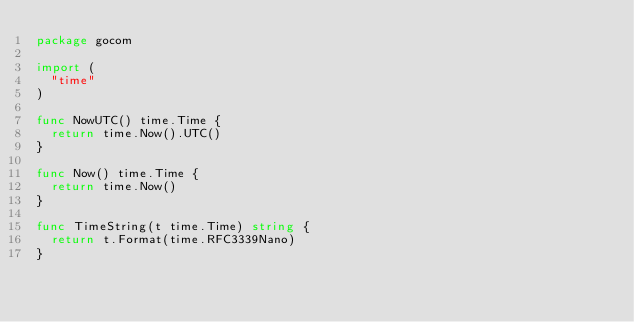Convert code to text. <code><loc_0><loc_0><loc_500><loc_500><_Go_>package gocom

import (
	"time"
)

func NowUTC() time.Time {
	return time.Now().UTC()
}

func Now() time.Time {
	return time.Now()
}

func TimeString(t time.Time) string {
	return t.Format(time.RFC3339Nano)
}
</code> 